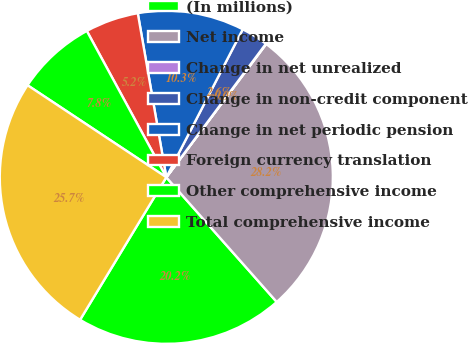Convert chart to OTSL. <chart><loc_0><loc_0><loc_500><loc_500><pie_chart><fcel>(In millions)<fcel>Net income<fcel>Change in net unrealized<fcel>Change in non-credit component<fcel>Change in net periodic pension<fcel>Foreign currency translation<fcel>Other comprehensive income<fcel>Total comprehensive income<nl><fcel>20.2%<fcel>28.23%<fcel>0.04%<fcel>2.61%<fcel>10.33%<fcel>5.18%<fcel>7.76%<fcel>25.66%<nl></chart> 